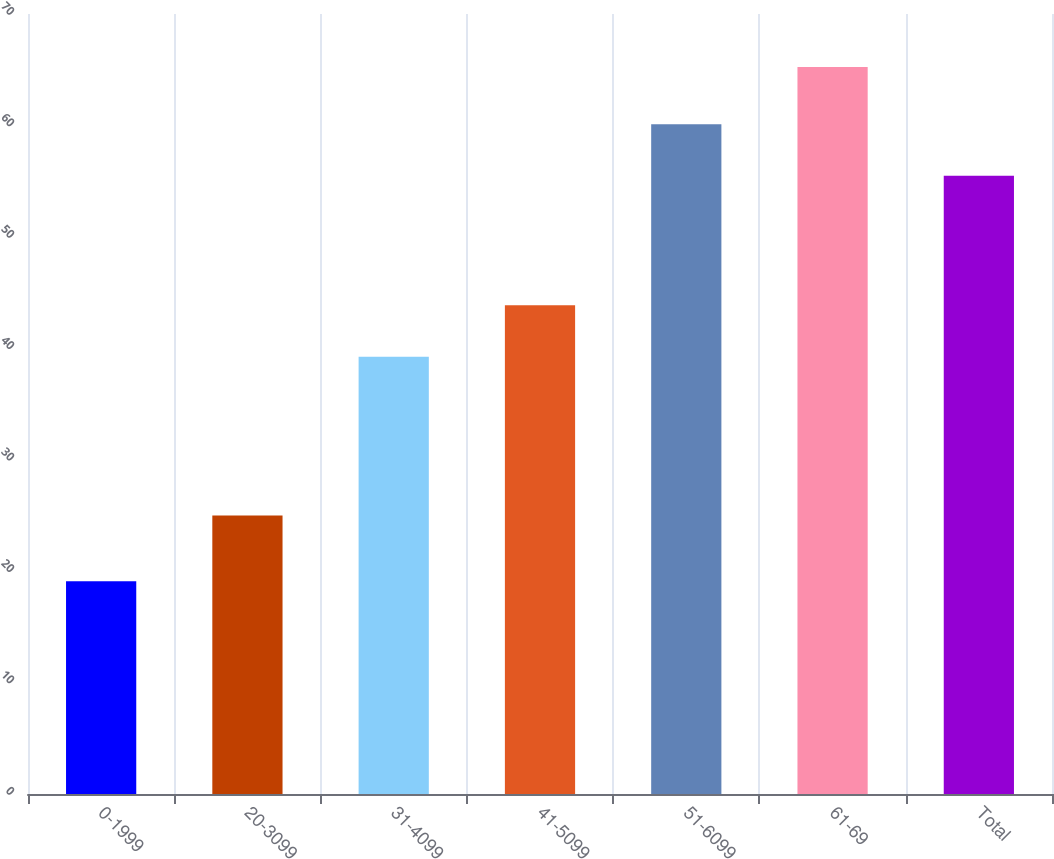<chart> <loc_0><loc_0><loc_500><loc_500><bar_chart><fcel>0-1999<fcel>20-3099<fcel>31-4099<fcel>41-5099<fcel>51-6099<fcel>61-69<fcel>Total<nl><fcel>19.1<fcel>25<fcel>39.25<fcel>43.86<fcel>60.1<fcel>65.24<fcel>55.49<nl></chart> 